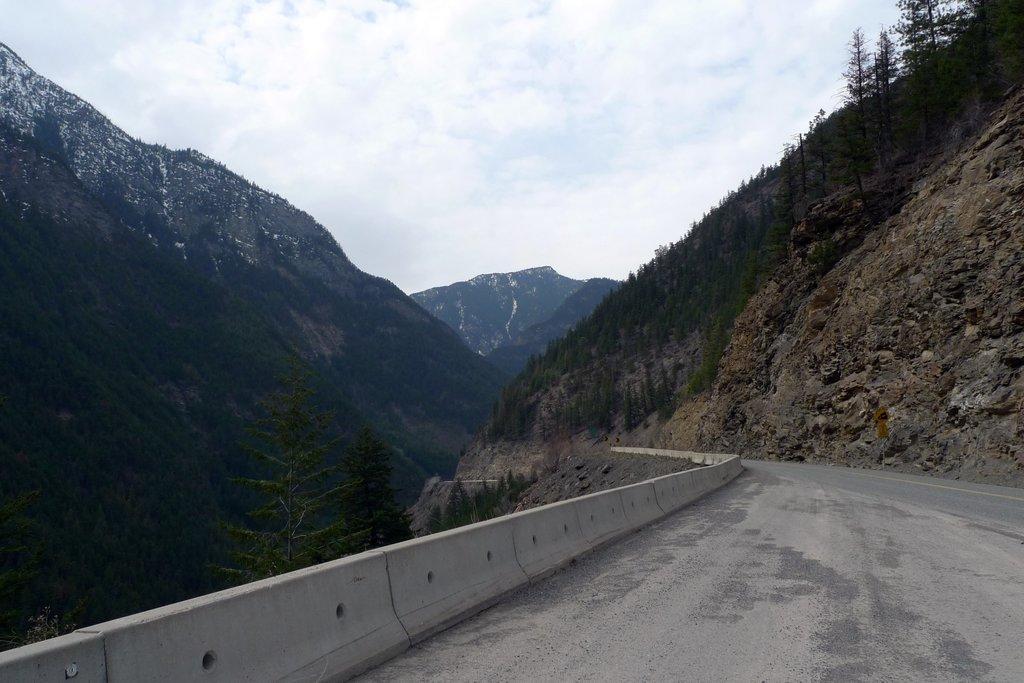Please provide a concise description of this image. In this image I can see the road. To the side of the road I can see the trees and mountains. In the background I can see the clouds and the sky. 